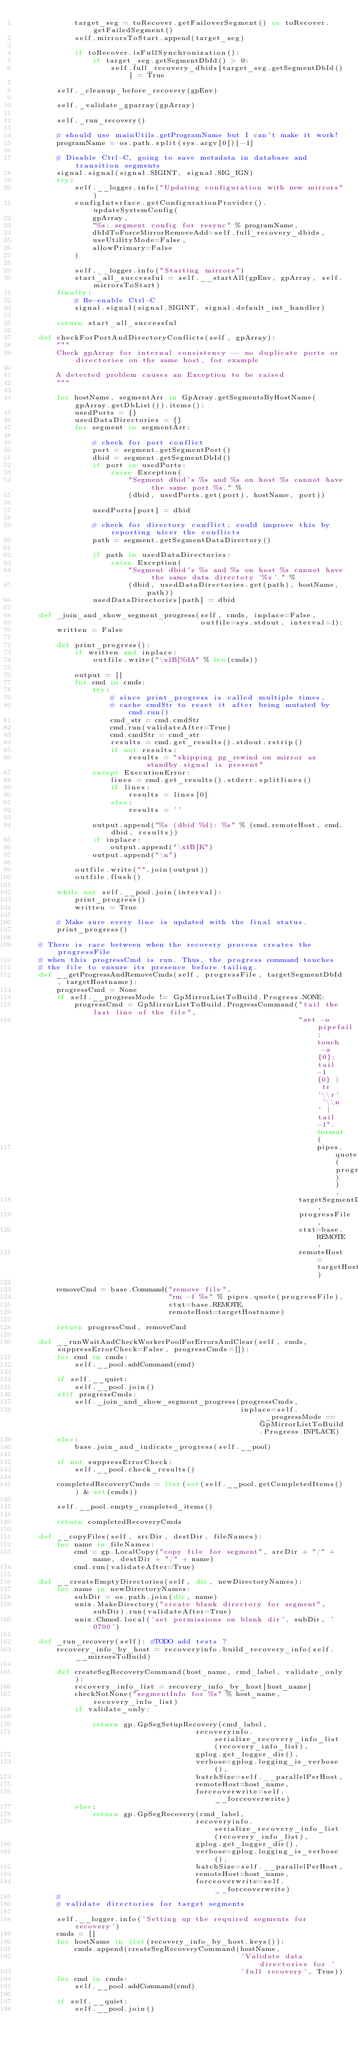<code> <loc_0><loc_0><loc_500><loc_500><_Python_>            target_seg = toRecover.getFailoverSegment() or toRecover.getFailedSegment()
            self.mirrorsToStart.append(target_seg)

            if toRecover.isFullSynchronization():
                if target_seg.getSegmentDbId() > 0:
                    self.full_recovery_dbids[target_seg.getSegmentDbId()] = True

        self._cleanup_before_recovery(gpEnv)

        self._validate_gparray(gpArray)

        self._run_recovery()

        # should use mainUtils.getProgramName but I can't make it work!
        programName = os.path.split(sys.argv[0])[-1]

        # Disable Ctrl-C, going to save metadata in database and transition segments
        signal.signal(signal.SIGINT, signal.SIG_IGN)
        try:
            self.__logger.info("Updating configuration with new mirrors")
            configInterface.getConfigurationProvider().updateSystemConfig(
                gpArray,
                "%s: segment config for resync" % programName,
                dbIdToForceMirrorRemoveAdd=self.full_recovery_dbids,
                useUtilityMode=False,
                allowPrimary=False
            )

            self.__logger.info("Starting mirrors")
            start_all_successful = self.__startAll(gpEnv, gpArray, self.mirrorsToStart)
        finally:
            # Re-enable Ctrl-C
            signal.signal(signal.SIGINT, signal.default_int_handler)

        return start_all_successful

    def checkForPortAndDirectoryConflicts(self, gpArray):
        """
        Check gpArray for internal consistency -- no duplicate ports or directories on the same host, for example

        A detected problem causes an Exception to be raised
        """

        for hostName, segmentArr in GpArray.getSegmentsByHostName(gpArray.getDbList()).items():
            usedPorts = {}
            usedDataDirectories = {}
            for segment in segmentArr:

                # check for port conflict
                port = segment.getSegmentPort()
                dbid = segment.getSegmentDbId()
                if port in usedPorts:
                    raise Exception(
                        "Segment dbid's %s and %s on host %s cannot have the same port %s." %
                        (dbid, usedPorts.get(port), hostName, port))

                usedPorts[port] = dbid

                # check for directory conflict; could improve this by reporting nicer the conflicts
                path = segment.getSegmentDataDirectory()

                if path in usedDataDirectories:
                    raise Exception(
                        "Segment dbid's %s and %s on host %s cannot have the same data directory '%s'." %
                        (dbid, usedDataDirectories.get(path), hostName, path))
                usedDataDirectories[path] = dbid

    def _join_and_show_segment_progress(self, cmds, inplace=False,
                                        outfile=sys.stdout, interval=1):
        written = False

        def print_progress():
            if written and inplace:
                outfile.write("\x1B[%dA" % len(cmds))

            output = []
            for cmd in cmds:
                try:
                    # since print_progress is called multiple times,
                    # cache cmdStr to reset it after being mutated by cmd.run()
                    cmd_str = cmd.cmdStr
                    cmd.run(validateAfter=True)
                    cmd.cmdStr = cmd_str
                    results = cmd.get_results().stdout.rstrip()
                    if not results:
                        results = "skipping pg_rewind on mirror as standby.signal is present"
                except ExecutionError:
                    lines = cmd.get_results().stderr.splitlines()
                    if lines:
                        results = lines[0]
                    else:
                        results = ''

                output.append("%s (dbid %d): %s" % (cmd.remoteHost, cmd.dbid, results))
                if inplace:
                    output.append("\x1B[K")
                output.append("\n")

            outfile.write("".join(output))
            outfile.flush()

        while not self.__pool.join(interval):
            print_progress()
            written = True

        # Make sure every line is updated with the final status.
        print_progress()

    # There is race between when the recovery process creates the progressFile
    # when this progressCmd is run. Thus, the progress command touches
    # the file to ensure its presence before tailing.
    def __getProgressAndRemoveCmds(self, progressFile, targetSegmentDbId, targetHostname):
        progressCmd = None
        if self.__progressMode != GpMirrorListToBuild.Progress.NONE:
            progressCmd = GpMirrorListToBuild.ProgressCommand("tail the last line of the file",
                                                              "set -o pipefail; touch -a {0}; tail -1 {0} | tr '\\r' '\\n' | tail -1".format(
                                                                  pipes.quote(progressFile)),
                                                              targetSegmentDbId,
                                                              progressFile,
                                                              ctxt=base.REMOTE,
                                                              remoteHost=targetHostname)

        removeCmd = base.Command("remove file",
                                 "rm -f %s" % pipes.quote(progressFile),
                                 ctxt=base.REMOTE,
                                 remoteHost=targetHostname)

        return progressCmd, removeCmd

    def __runWaitAndCheckWorkerPoolForErrorsAndClear(self, cmds, suppressErrorCheck=False, progressCmds=[]):
        for cmd in cmds:
            self.__pool.addCommand(cmd)

        if self.__quiet:
            self.__pool.join()
        elif progressCmds:
            self._join_and_show_segment_progress(progressCmds,
                                                 inplace=self.__progressMode == GpMirrorListToBuild.Progress.INPLACE)
        else:
            base.join_and_indicate_progress(self.__pool)

        if not suppressErrorCheck:
            self.__pool.check_results()

        completedRecoveryCmds = list(set(self.__pool.getCompletedItems()) & set(cmds))

        self.__pool.empty_completed_items()

        return completedRecoveryCmds

    def __copyFiles(self, srcDir, destDir, fileNames):
        for name in fileNames:
            cmd = gp.LocalCopy("copy file for segment", srcDir + "/" + name, destDir + "/" + name)
            cmd.run(validateAfter=True)

    def __createEmptyDirectories(self, dir, newDirectoryNames):
        for name in newDirectoryNames:
            subDir = os.path.join(dir, name)
            unix.MakeDirectory("create blank directory for segment", subDir).run(validateAfter=True)
            unix.Chmod.local('set permissions on blank dir', subDir, '0700')

    def _run_recovery(self): #TODO add tests ?
        recovery_info_by_host = recoveryinfo.build_recovery_info(self.__mirrorsToBuild)

        def createSegRecoveryCommand(host_name, cmd_label, validate_only):
            recovery_info_list = recovery_info_by_host[host_name]
            checkNotNone("segmentInfo for %s" % host_name, recovery_info_list)
            if validate_only:

                return gp.GpSegSetupRecovery(cmd_label,
                                       recoveryinfo.serialize_recovery_info_list(recovery_info_list),
                                       gplog.get_logger_dir(),
                                       verbose=gplog.logging_is_verbose(),
                                       batchSize=self.__parallelPerHost,
                                       remoteHost=host_name,
                                       forceoverwrite=self.__forceoverwrite)
            else:
                return gp.GpSegRecovery(cmd_label,
                                       recoveryinfo.serialize_recovery_info_list(recovery_info_list),
                                       gplog.get_logger_dir(),
                                       verbose=gplog.logging_is_verbose(),
                                       batchSize=self.__parallelPerHost,
                                       remoteHost=host_name,
                                       forceoverwrite=self.__forceoverwrite)
        #
        # validate directories for target segments

        self.__logger.info('Setting up the required segments for recovery')
        cmds = []
        for hostName in list(recovery_info_by_host.keys()):
            cmds.append(createSegRecoveryCommand(hostName,
                                                 'Validate data directories for '
                                                 'full recovery', True))
        for cmd in cmds:
            self.__pool.addCommand(cmd)

        if self.__quiet:
            self.__pool.join()</code> 